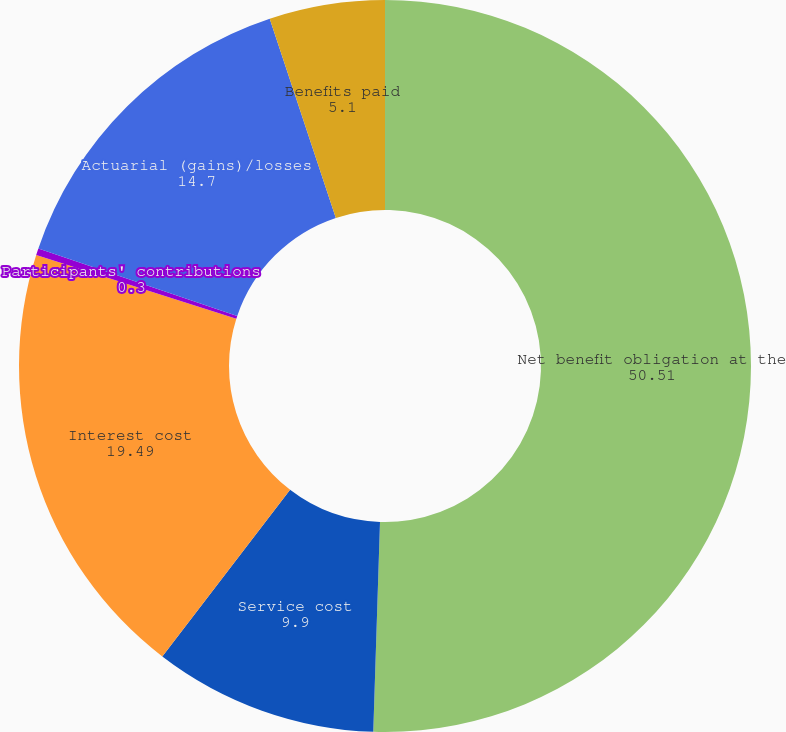Convert chart to OTSL. <chart><loc_0><loc_0><loc_500><loc_500><pie_chart><fcel>Net benefit obligation at the<fcel>Service cost<fcel>Interest cost<fcel>Participants' contributions<fcel>Actuarial (gains)/losses<fcel>Benefits paid<nl><fcel>50.51%<fcel>9.9%<fcel>19.49%<fcel>0.3%<fcel>14.7%<fcel>5.1%<nl></chart> 